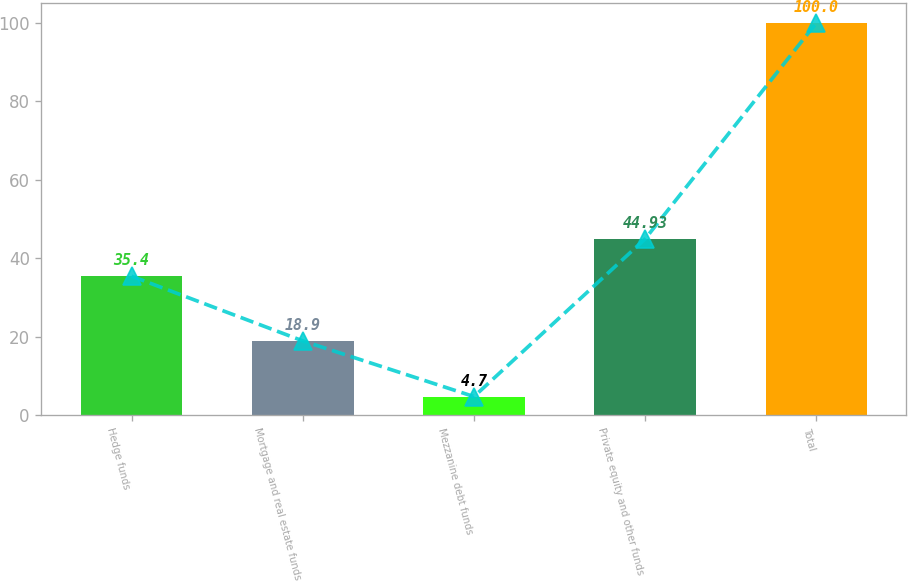Convert chart. <chart><loc_0><loc_0><loc_500><loc_500><bar_chart><fcel>Hedge funds<fcel>Mortgage and real estate funds<fcel>Mezzanine debt funds<fcel>Private equity and other funds<fcel>Total<nl><fcel>35.4<fcel>18.9<fcel>4.7<fcel>44.93<fcel>100<nl></chart> 